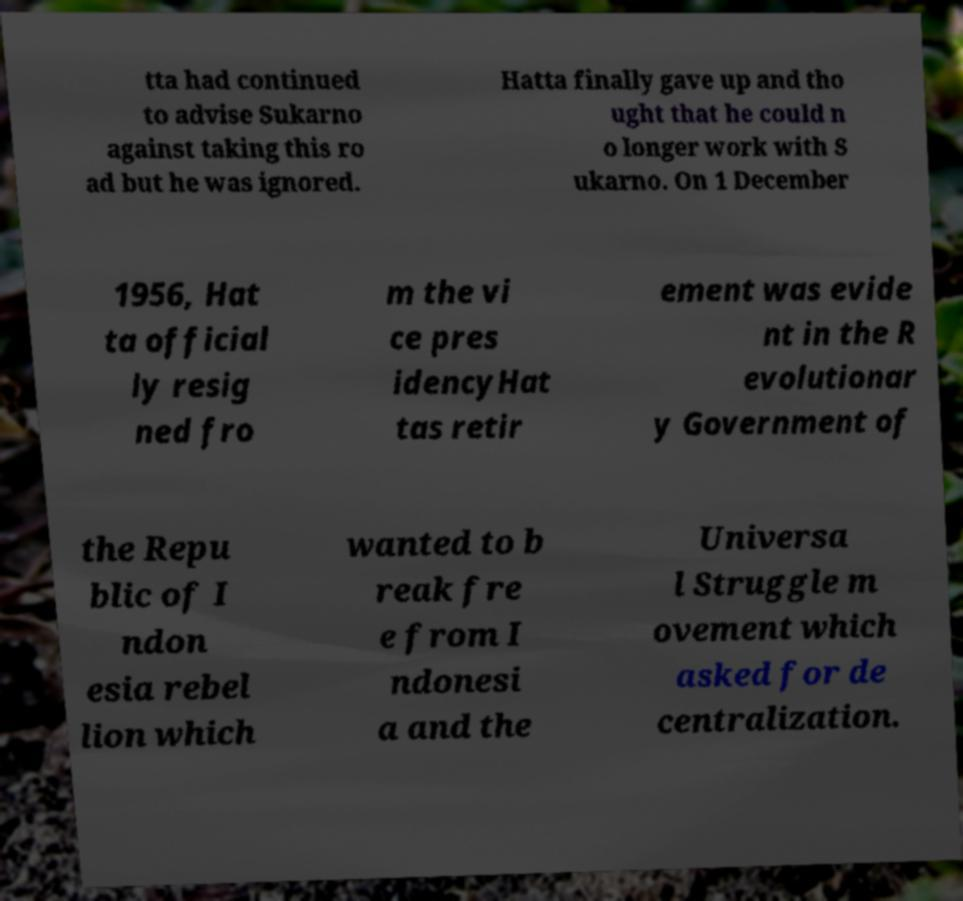What messages or text are displayed in this image? I need them in a readable, typed format. tta had continued to advise Sukarno against taking this ro ad but he was ignored. Hatta finally gave up and tho ught that he could n o longer work with S ukarno. On 1 December 1956, Hat ta official ly resig ned fro m the vi ce pres idencyHat tas retir ement was evide nt in the R evolutionar y Government of the Repu blic of I ndon esia rebel lion which wanted to b reak fre e from I ndonesi a and the Universa l Struggle m ovement which asked for de centralization. 